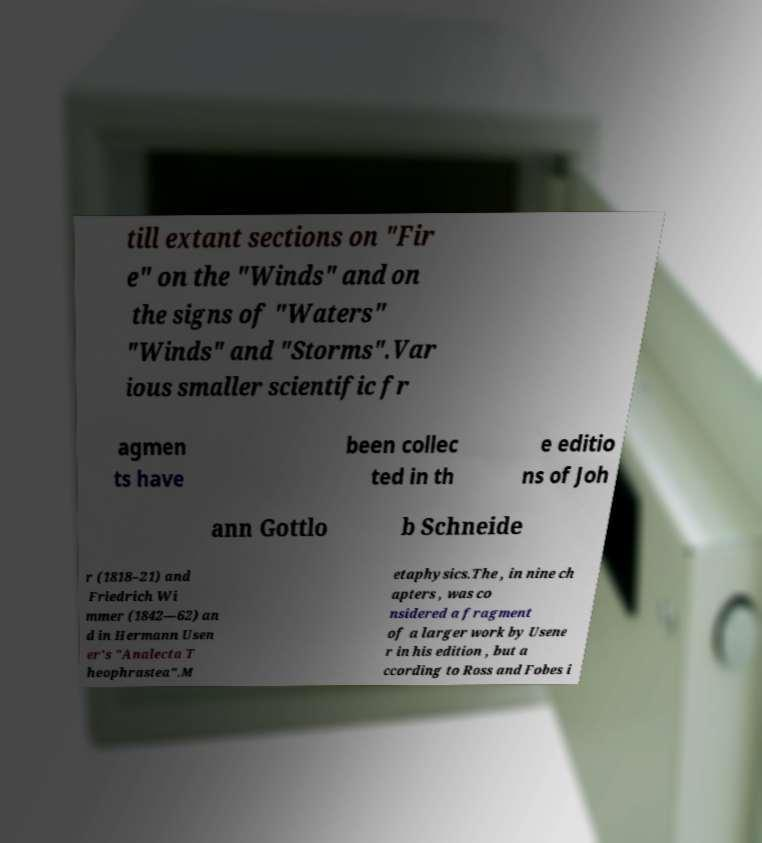Can you accurately transcribe the text from the provided image for me? till extant sections on "Fir e" on the "Winds" and on the signs of "Waters" "Winds" and "Storms".Var ious smaller scientific fr agmen ts have been collec ted in th e editio ns of Joh ann Gottlo b Schneide r (1818–21) and Friedrich Wi mmer (1842—62) an d in Hermann Usen er's "Analecta T heophrastea".M etaphysics.The , in nine ch apters , was co nsidered a fragment of a larger work by Usene r in his edition , but a ccording to Ross and Fobes i 